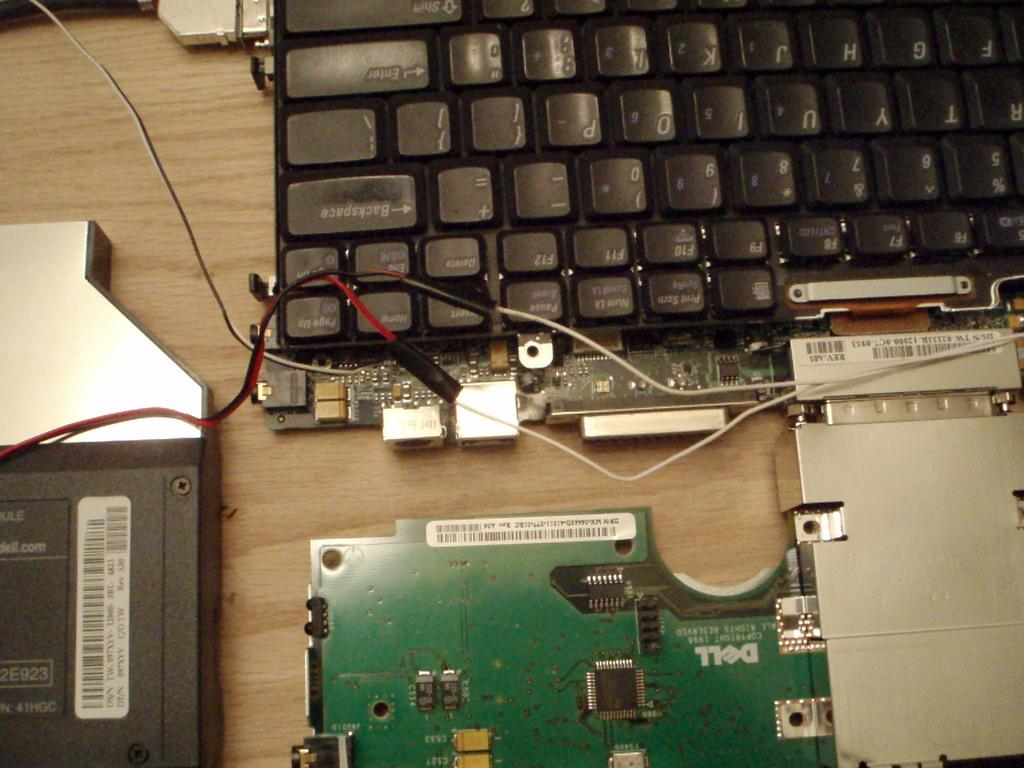<image>
Share a concise interpretation of the image provided. A keyboard that is torn apart but the backspace button is in tact. 